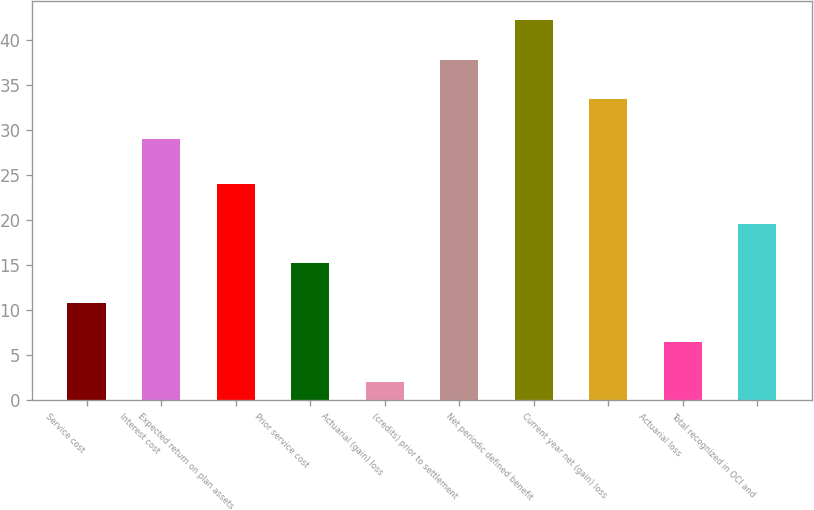Convert chart. <chart><loc_0><loc_0><loc_500><loc_500><bar_chart><fcel>Service cost<fcel>Interest cost<fcel>Expected return on plan assets<fcel>Prior service cost<fcel>Actuarial (gain) loss<fcel>(credits) prior to settlement<fcel>Net periodic defined benefit<fcel>Current year net (gain) loss<fcel>Actuarial loss<fcel>Total recognized in OCI and<nl><fcel>10.8<fcel>29<fcel>24<fcel>15.2<fcel>2<fcel>37.8<fcel>42.2<fcel>33.4<fcel>6.4<fcel>19.6<nl></chart> 